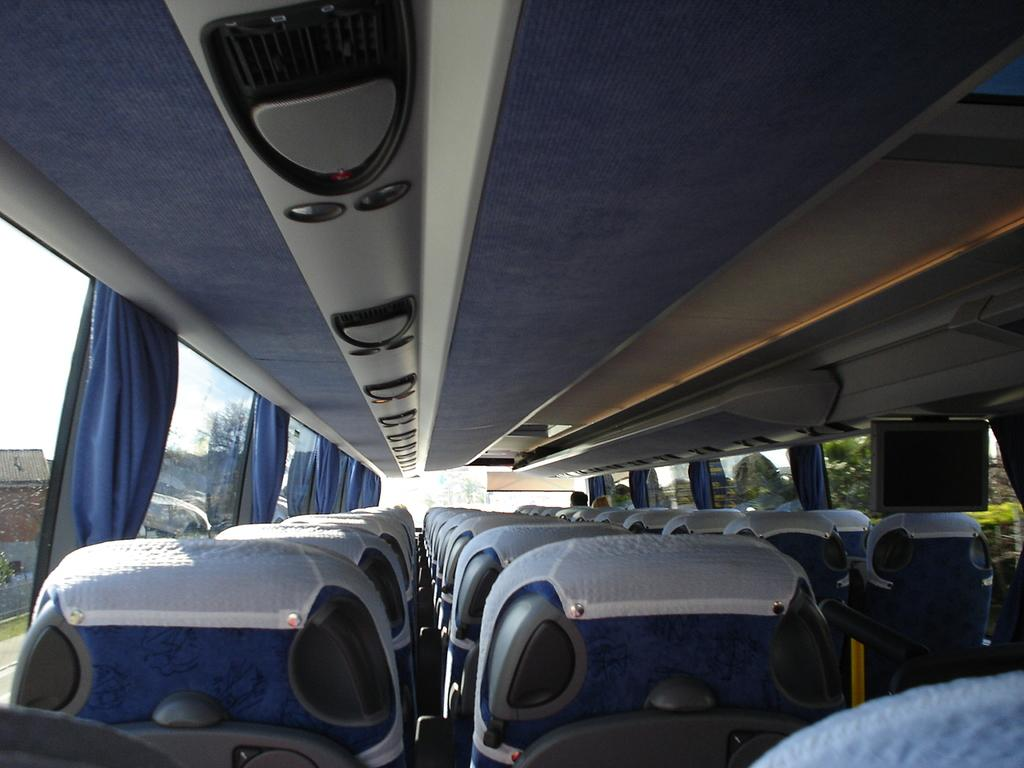Where was the image captured? The image was captured inside a bus. What can be observed about the seating arrangement in the bus? There are empty seats in the bus. Where are the people located in the bus? There are people at the front side of the bus. What can be seen in the background of the image? There are houses, trees, and the sky visible in the background of the image. How many cattle can be seen grazing near the houses in the background of the image? There are no cattle visible in the image; only houses, trees, and the sky can be seen in the background. What type of bulb is used to illuminate the interior of the bus in the image? The image does not provide information about the type of bulb used to illuminate the interior of the bus, as it focuses on the people and the background elements. 